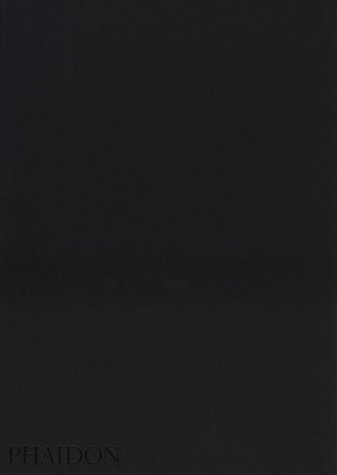Can you describe some unique cultural aspects of the Mennonite community as detailed in the book? The book by Larry Towell, 'The Mennonites', offers an in-depth look at the Mennonite community, showcasing their traditional attire, simple living, and strong community bonds, through stunning black and white photography. 